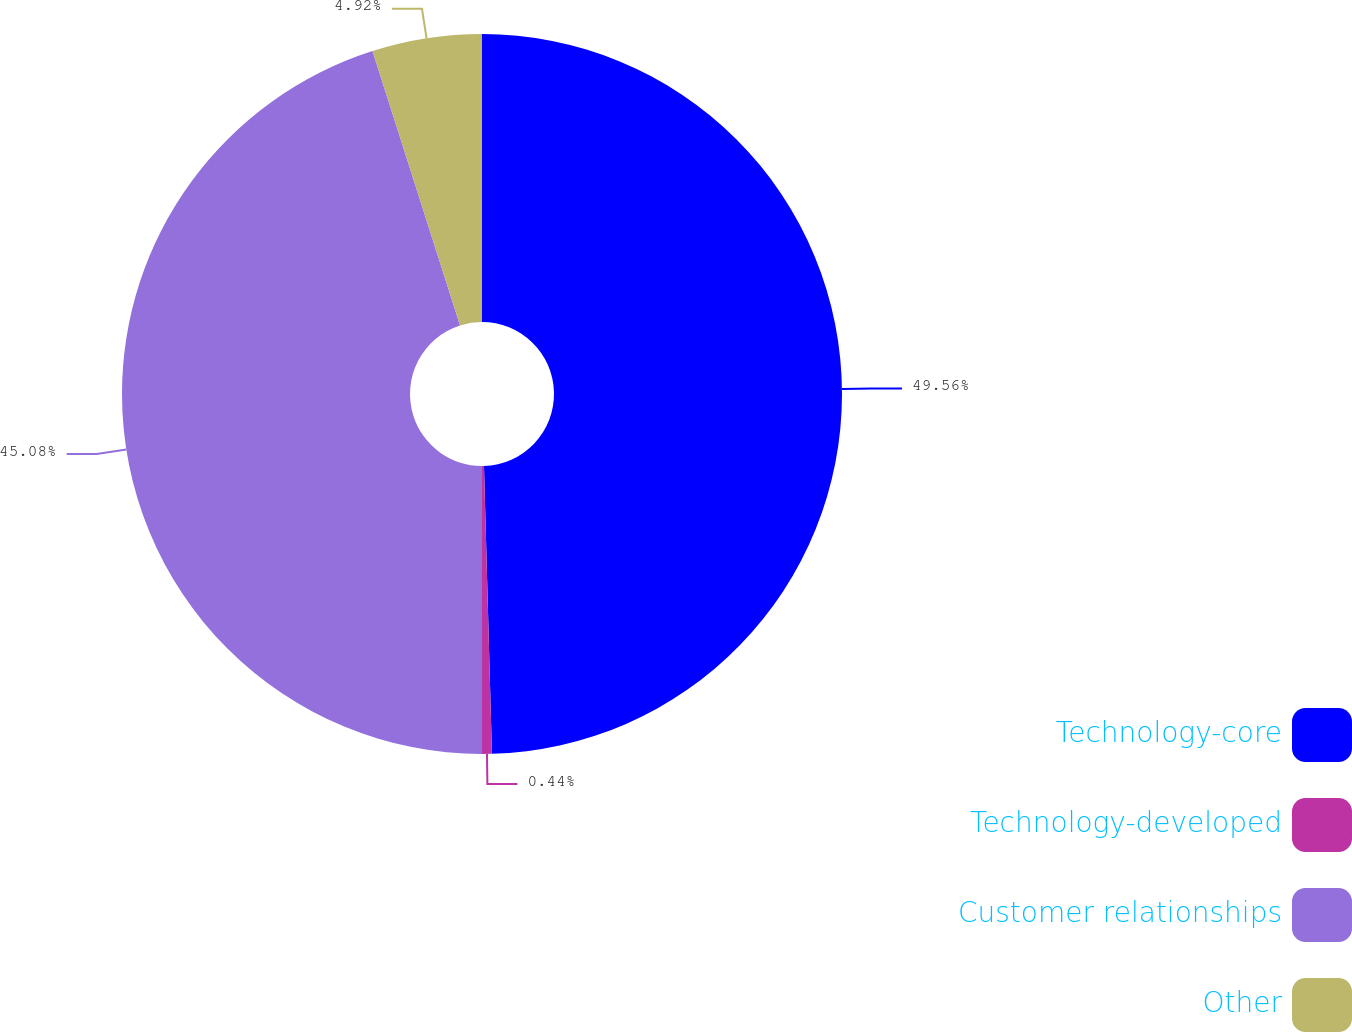<chart> <loc_0><loc_0><loc_500><loc_500><pie_chart><fcel>Technology-core<fcel>Technology-developed<fcel>Customer relationships<fcel>Other<nl><fcel>49.56%<fcel>0.44%<fcel>45.08%<fcel>4.92%<nl></chart> 